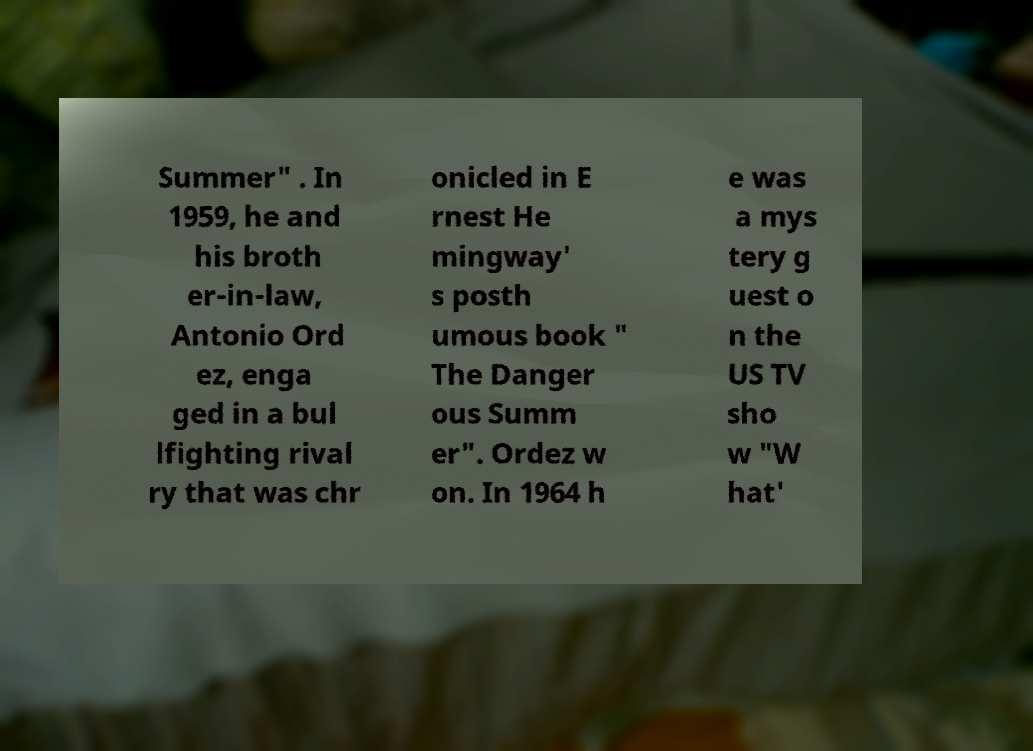Please identify and transcribe the text found in this image. Summer" . In 1959, he and his broth er-in-law, Antonio Ord ez, enga ged in a bul lfighting rival ry that was chr onicled in E rnest He mingway' s posth umous book " The Danger ous Summ er". Ordez w on. In 1964 h e was a mys tery g uest o n the US TV sho w "W hat' 